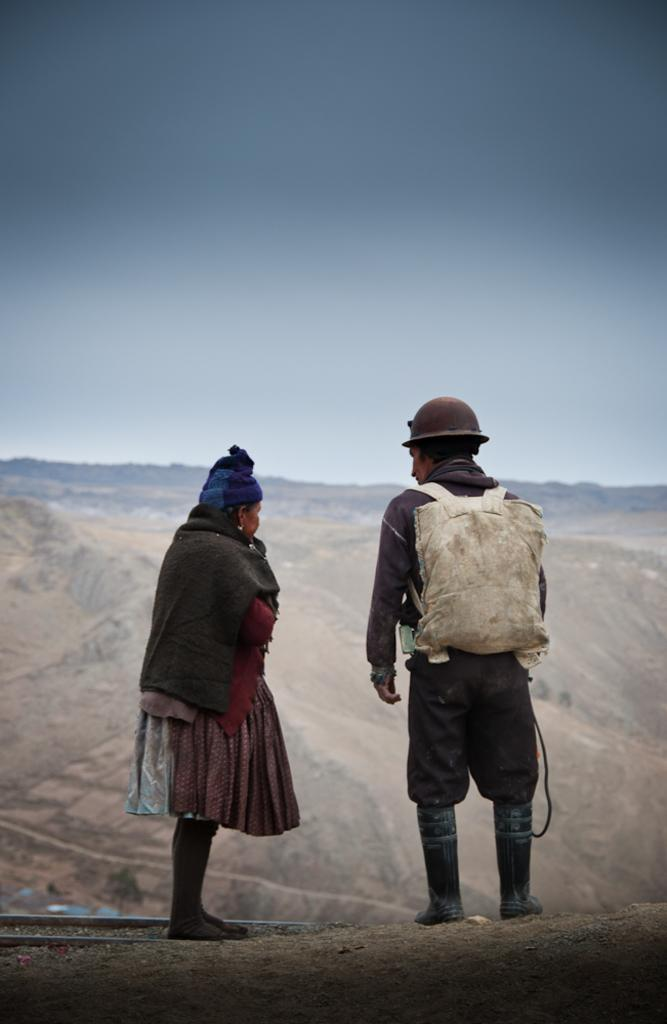How many people are in the image? There are two people standing in the front of the image. What are the men wearing on their heads? The man on the right side is wearing a helmet. What else is the man on the right side carrying? The man on the right side is also wearing a bag. What can be seen at the top of the image? The sky is visible at the top of the image. What is the argument about between the two people in the image? There is no argument depicted in the image; it only shows two people standing with a helmet and a bag. 